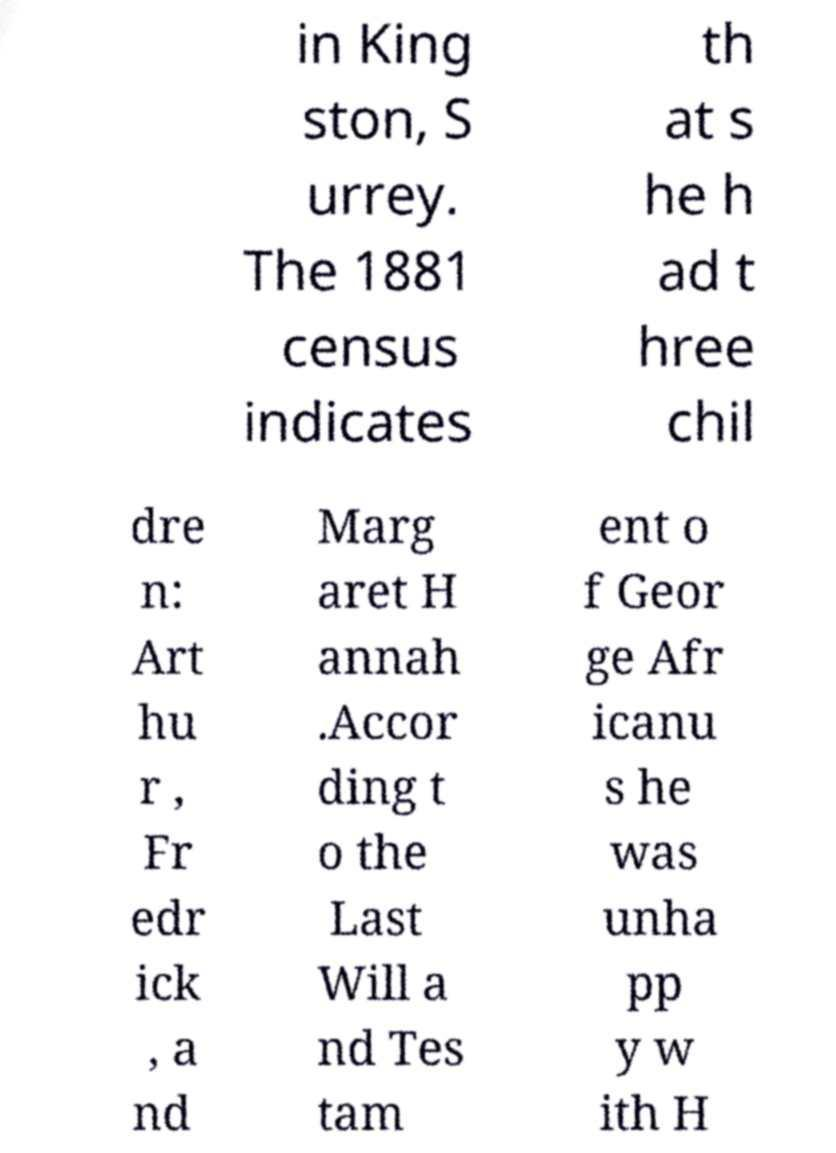What messages or text are displayed in this image? I need them in a readable, typed format. in King ston, S urrey. The 1881 census indicates th at s he h ad t hree chil dre n: Art hu r , Fr edr ick , a nd Marg aret H annah .Accor ding t o the Last Will a nd Tes tam ent o f Geor ge Afr icanu s he was unha pp y w ith H 